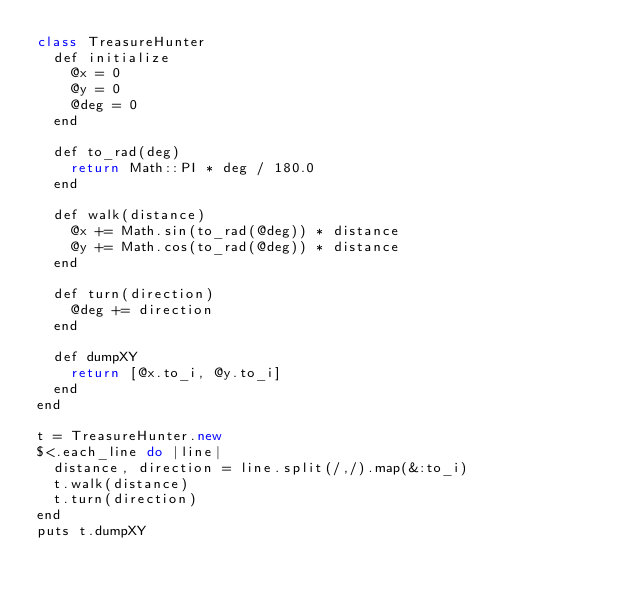Convert code to text. <code><loc_0><loc_0><loc_500><loc_500><_D_>class TreasureHunter
  def initialize
    @x = 0
    @y = 0
    @deg = 0
  end

  def to_rad(deg)
    return Math::PI * deg / 180.0
  end
  
  def walk(distance)
    @x += Math.sin(to_rad(@deg)) * distance
    @y += Math.cos(to_rad(@deg)) * distance
  end

  def turn(direction)
    @deg += direction
  end

  def dumpXY
    return [@x.to_i, @y.to_i]
  end
end

t = TreasureHunter.new
$<.each_line do |line|
  distance, direction = line.split(/,/).map(&:to_i)
  t.walk(distance)
  t.turn(direction)
end
puts t.dumpXY</code> 